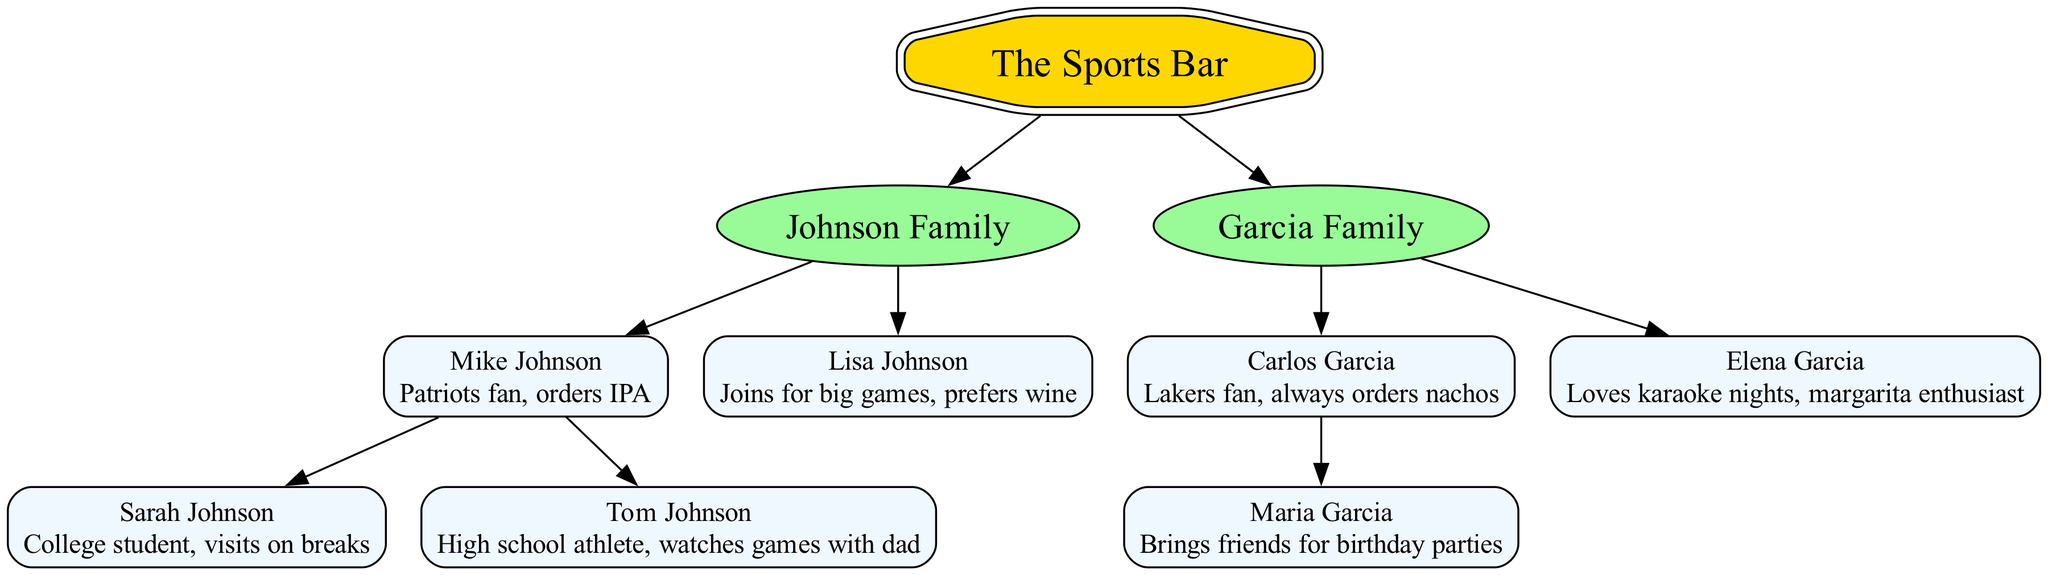What's the favorite team of Mike Johnson? The diagram indicates that Mike Johnson is a Patriots fan, which is explicitly mentioned in his description.
Answer: Patriots fan How many children does Carlos Garcia have? By examining the diagram, it's clear that Carlos Garcia has one child, Maria Garcia, as indicated under his entry.
Answer: 1 Which family enjoys karaoke nights? The diagram shows that Elena Garcia is indicated as someone who loves karaoke nights, listed under the Garcia family.
Answer: Elena Garcia What does Lisa Johnson prefer to drink? According to the diagram, Lisa Johnson prefers wine, as stated in her description.
Answer: Wine Who brings friends for birthday parties? The diagram indicates that Maria Garcia is the family member who brings friends for birthday parties.
Answer: Maria Garcia How many total families are represented in the diagram? The diagram points out two families: the Johnson Family and the Garcia Family, making the total count two.
Answer: 2 Which family does Tom Johnson belong to? By tracing the diagram, Tom Johnson is shown as a member of the Johnson Family.
Answer: Johnson Family What is the relationship between Sarah Johnson and Mike Johnson? The diagram clearly shows that Sarah Johnson is a child of Mike Johnson, denoting a parent-child relationship.
Answer: Child Which family has members who are sports fans? The diagram indicates that both Johnson and Garcia families have members who express their support for specific sports teams, making both families sport fans.
Answer: Both families 